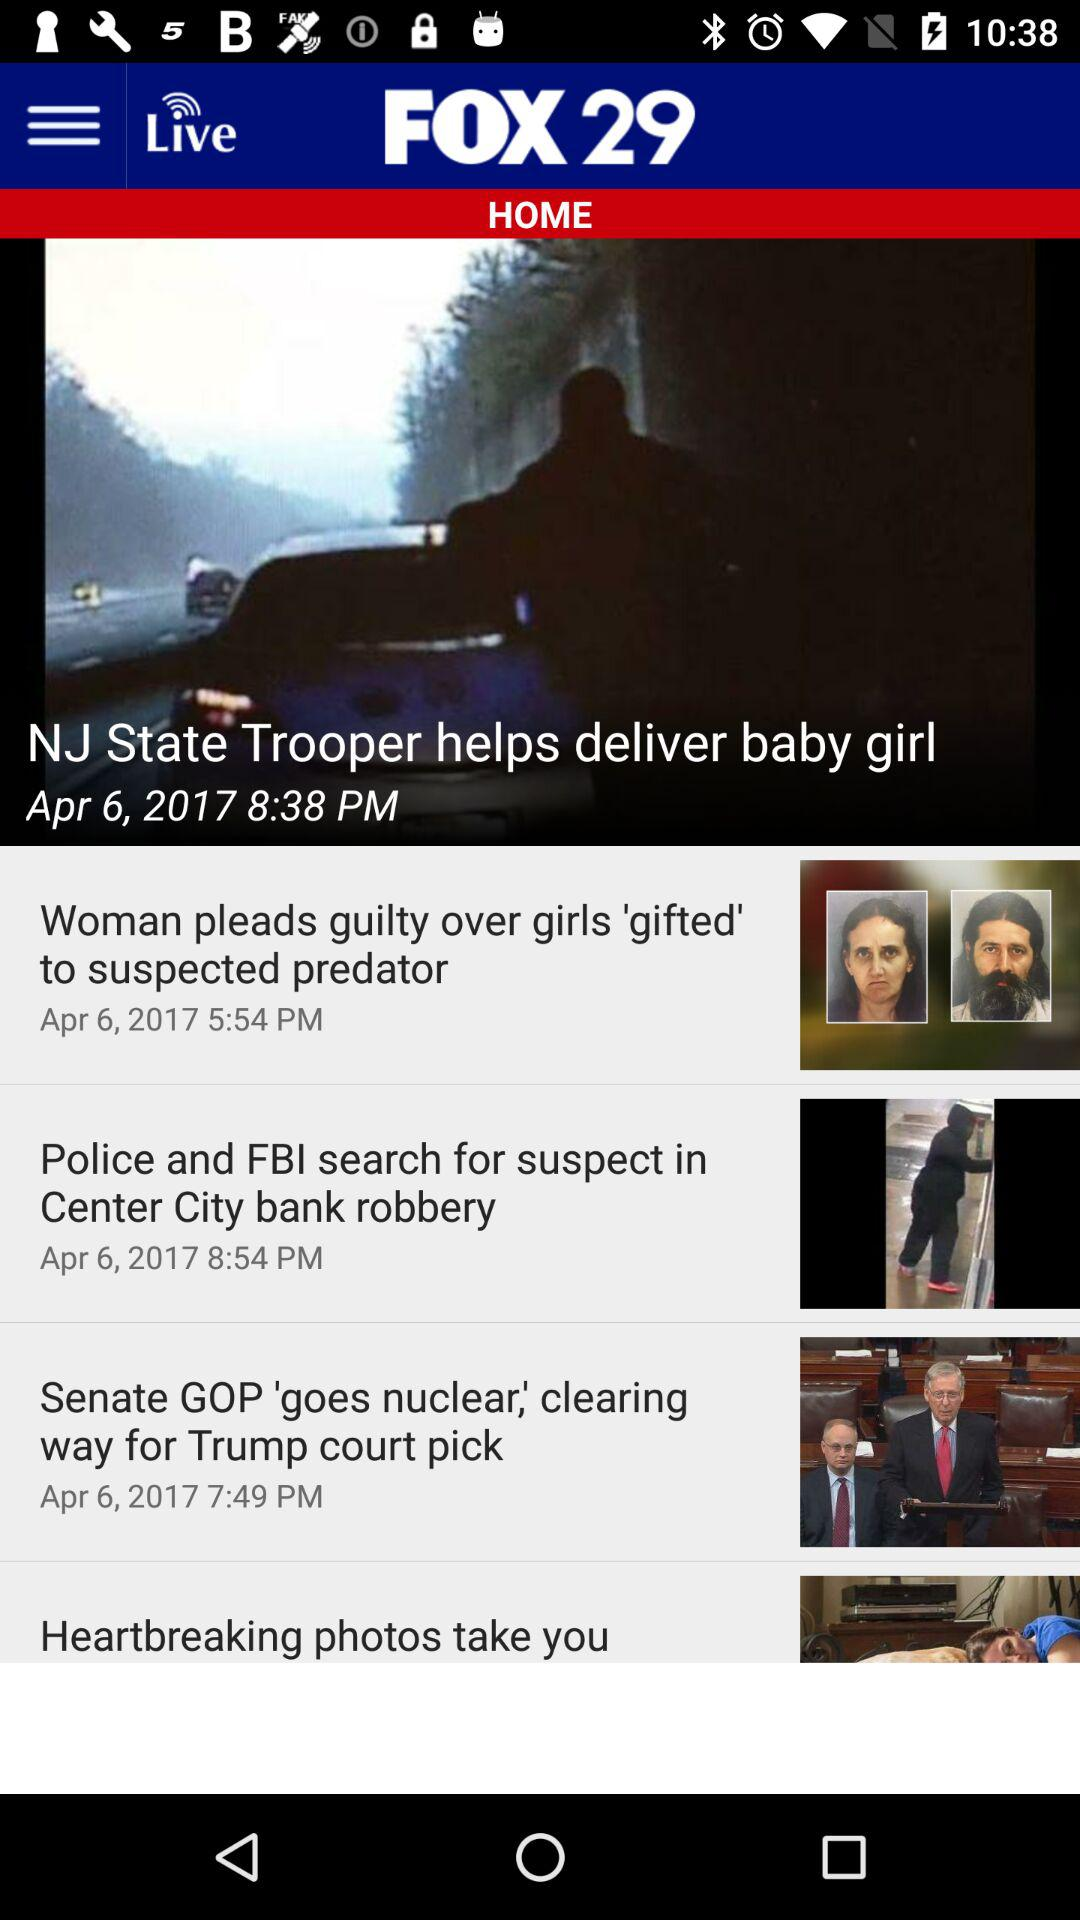At what time is the news "Police and FBI search for suspect in Center City bank robbery" updated? The updated time is 8:54 PM. 